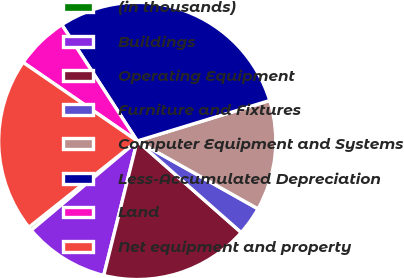Convert chart. <chart><loc_0><loc_0><loc_500><loc_500><pie_chart><fcel>(in thousands)<fcel>Buildings<fcel>Operating Equipment<fcel>Furniture and Fixtures<fcel>Computer Equipment and Systems<fcel>Less-Accumulated Depreciation<fcel>Land<fcel>Net equipment and property<nl><fcel>0.44%<fcel>9.97%<fcel>17.4%<fcel>3.34%<fcel>12.87%<fcel>29.44%<fcel>6.24%<fcel>20.3%<nl></chart> 